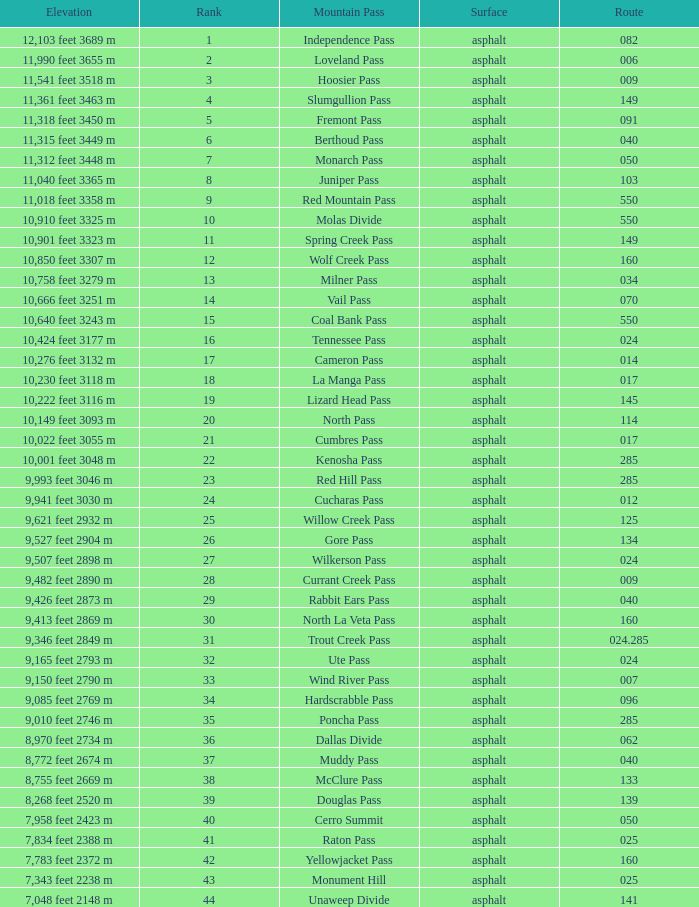What Mountain Pass has an Elevation of 10,001 feet 3048 m? Kenosha Pass. 